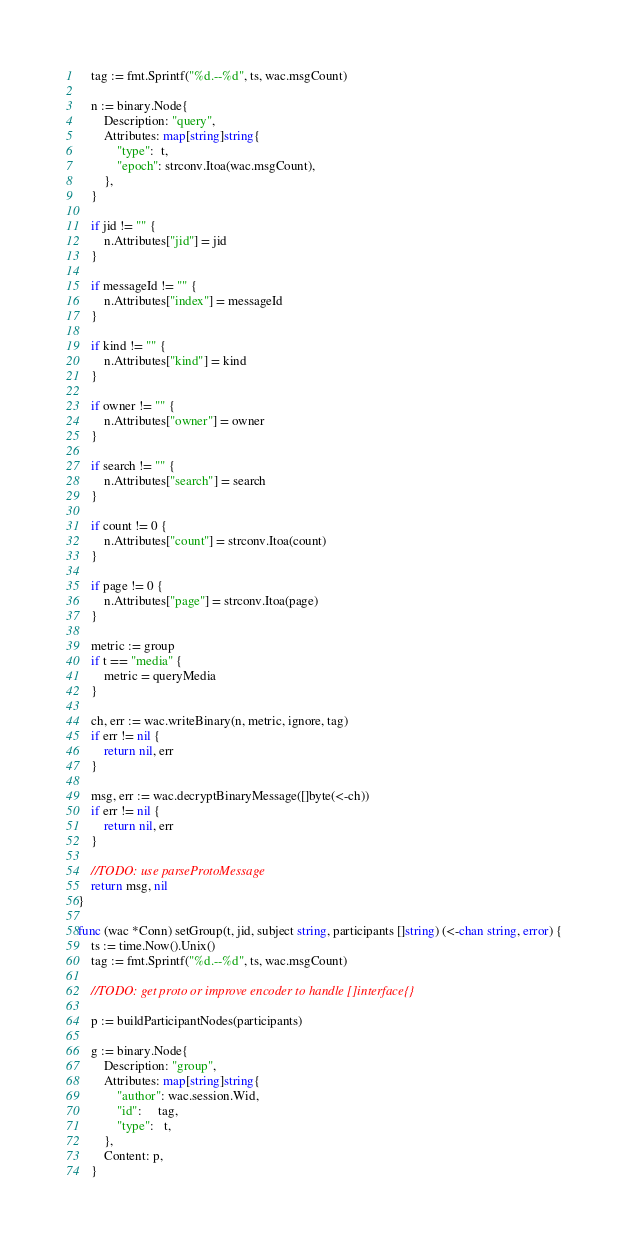Convert code to text. <code><loc_0><loc_0><loc_500><loc_500><_Go_>	tag := fmt.Sprintf("%d.--%d", ts, wac.msgCount)

	n := binary.Node{
		Description: "query",
		Attributes: map[string]string{
			"type":  t,
			"epoch": strconv.Itoa(wac.msgCount),
		},
	}

	if jid != "" {
		n.Attributes["jid"] = jid
	}

	if messageId != "" {
		n.Attributes["index"] = messageId
	}

	if kind != "" {
		n.Attributes["kind"] = kind
	}

	if owner != "" {
		n.Attributes["owner"] = owner
	}

	if search != "" {
		n.Attributes["search"] = search
	}

	if count != 0 {
		n.Attributes["count"] = strconv.Itoa(count)
	}

	if page != 0 {
		n.Attributes["page"] = strconv.Itoa(page)
	}

	metric := group
	if t == "media" {
		metric = queryMedia
	}

	ch, err := wac.writeBinary(n, metric, ignore, tag)
	if err != nil {
		return nil, err
	}

	msg, err := wac.decryptBinaryMessage([]byte(<-ch))
	if err != nil {
		return nil, err
	}

	//TODO: use parseProtoMessage
	return msg, nil
}

func (wac *Conn) setGroup(t, jid, subject string, participants []string) (<-chan string, error) {
	ts := time.Now().Unix()
	tag := fmt.Sprintf("%d.--%d", ts, wac.msgCount)

	//TODO: get proto or improve encoder to handle []interface{}

	p := buildParticipantNodes(participants)

	g := binary.Node{
		Description: "group",
		Attributes: map[string]string{
			"author": wac.session.Wid,
			"id":     tag,
			"type":   t,
		},
		Content: p,
	}
</code> 